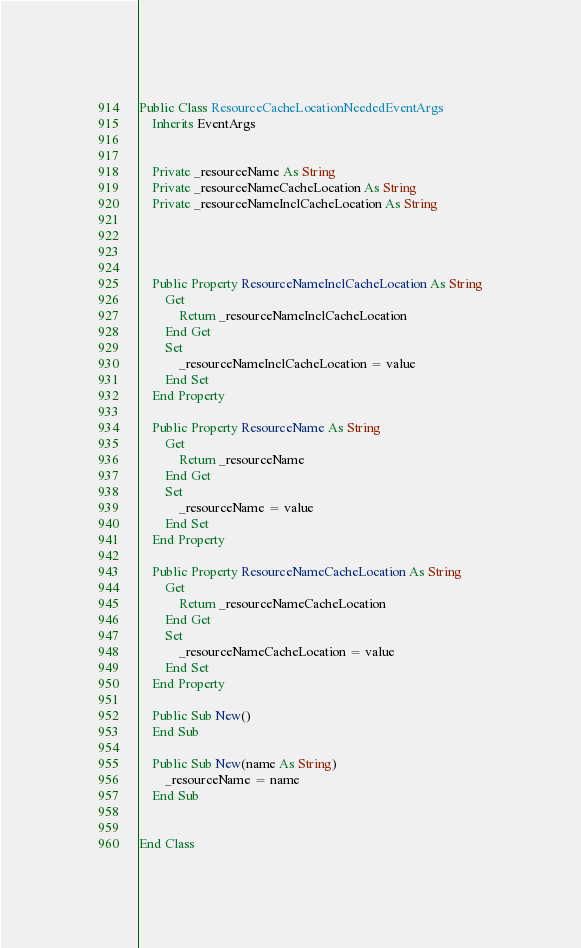Convert code to text. <code><loc_0><loc_0><loc_500><loc_500><_VisualBasic_>


Public Class ResourceCacheLocationNeededEventArgs
    Inherits EventArgs


    Private _resourceName As String
    Private _resourceNameCacheLocation As String
    Private _resourceNameInclCacheLocation As String




    Public Property ResourceNameInclCacheLocation As String
        Get
            Return _resourceNameInclCacheLocation
        End Get
        Set
            _resourceNameInclCacheLocation = value
        End Set
    End Property

    Public Property ResourceName As String
        Get
            Return _resourceName
        End Get
        Set
            _resourceName = value
        End Set
    End Property

    Public Property ResourceNameCacheLocation As String
        Get
            Return _resourceNameCacheLocation
        End Get
        Set
            _resourceNameCacheLocation = value
        End Set
    End Property

    Public Sub New()
    End Sub

    Public Sub New(name As String)
        _resourceName = name
    End Sub


End Class

</code> 